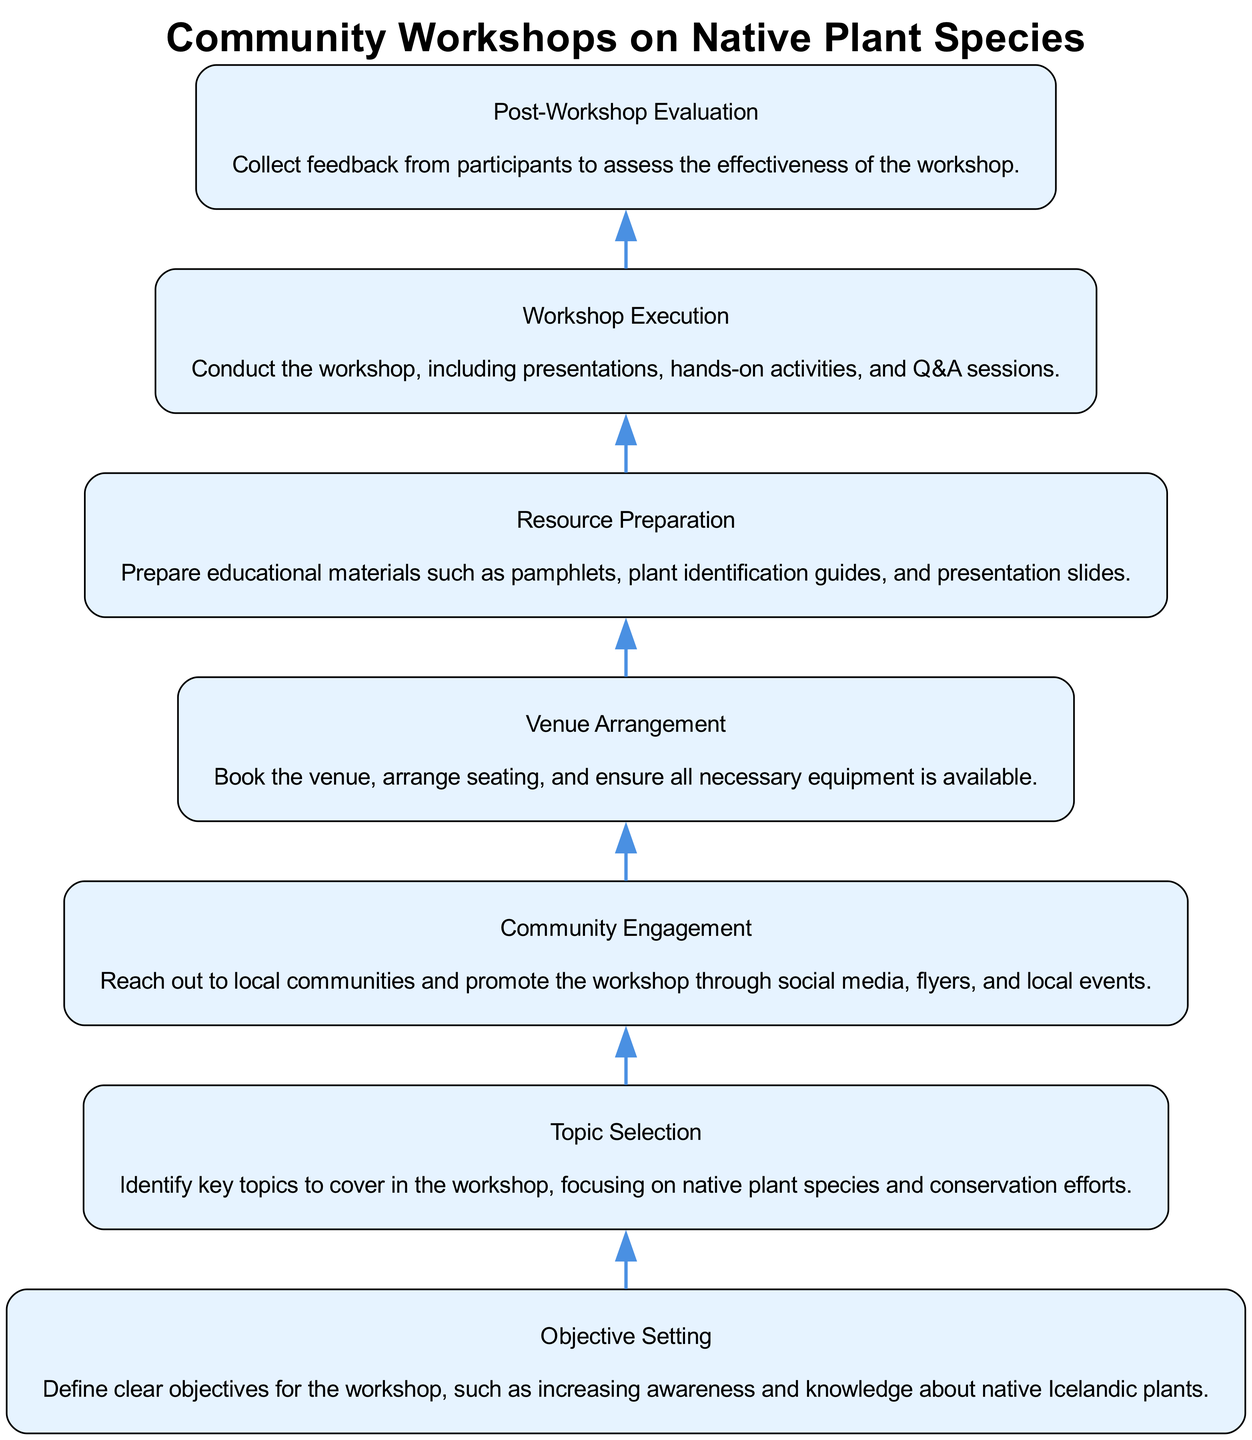What is the last step in the workshop organization process? The last step listed in the diagram is "Post-Workshop Evaluation". It's located at the bottom of the flowchart, indicating it is the final action taken once all previous steps have been completed.
Answer: Post-Workshop Evaluation How many steps are there in total? By counting all the unique nodes listed in the diagram, there are a total of seven steps in the process of organizing community workshops on native plant species.
Answer: 7 What is the main focus of the "Topic Selection" step? "Topic Selection" focuses on identifying key topics related to native plant species and conservation efforts. This step emphasizes the importance of choosing subjects that will be relevant and beneficial for the workshop.
Answer: Native plant species and conservation efforts In which step does community outreach occur? Community outreach takes place during the "Community Engagement" step. This is where effort is put into reaching local communities to raise awareness and encourage participation in the workshop.
Answer: Community Engagement Which step comes directly before "Workshop Execution"? The step that directly precedes "Workshop Execution" is "Resource Preparation". This indicates that preparation of educational materials must be completed before the actual workshop can take place.
Answer: Resource Preparation What objectives should be defined before the workshop? The "Objective Setting" step involves defining clear objectives aimed at increasing awareness and knowledge about native Icelandic plants, ensuring that participants have clear goals to achieve from the workshop.
Answer: Increasing awareness and knowledge about native Icelandic plants What is the primary task for the "Venue Arrangement" step? The primary task for "Venue Arrangement" is to book a suitable venue and ensure that necessary equipment is available for the workshop. This is crucial for creating a conducive environment for the participants.
Answer: Book the venue and ensure necessary equipment is available What happens after "Objective Setting"? Following "Objective Setting", the next step is "Topic Selection". This shows that after establishing goals for the workshop, the focus shifts to determining the content that will be discussed.
Answer: Topic Selection 